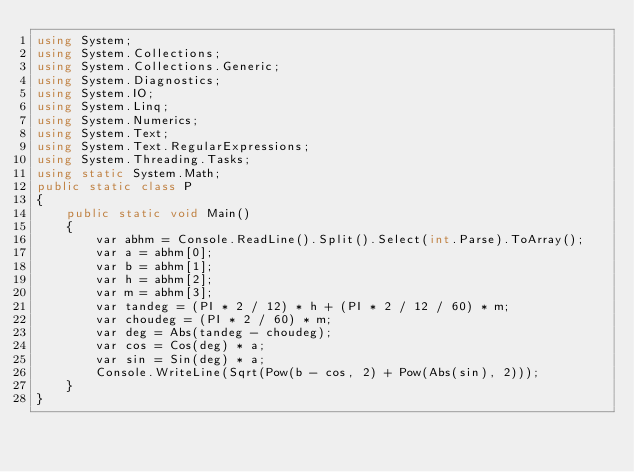Convert code to text. <code><loc_0><loc_0><loc_500><loc_500><_C#_>using System;
using System.Collections;
using System.Collections.Generic;
using System.Diagnostics;
using System.IO;
using System.Linq;
using System.Numerics;
using System.Text;
using System.Text.RegularExpressions;
using System.Threading.Tasks;
using static System.Math;
public static class P
{
    public static void Main()
    {
        var abhm = Console.ReadLine().Split().Select(int.Parse).ToArray();
        var a = abhm[0];
        var b = abhm[1];
        var h = abhm[2];
        var m = abhm[3];
        var tandeg = (PI * 2 / 12) * h + (PI * 2 / 12 / 60) * m;
        var choudeg = (PI * 2 / 60) * m;
        var deg = Abs(tandeg - choudeg);
        var cos = Cos(deg) * a;
        var sin = Sin(deg) * a;
        Console.WriteLine(Sqrt(Pow(b - cos, 2) + Pow(Abs(sin), 2)));
    }
}</code> 